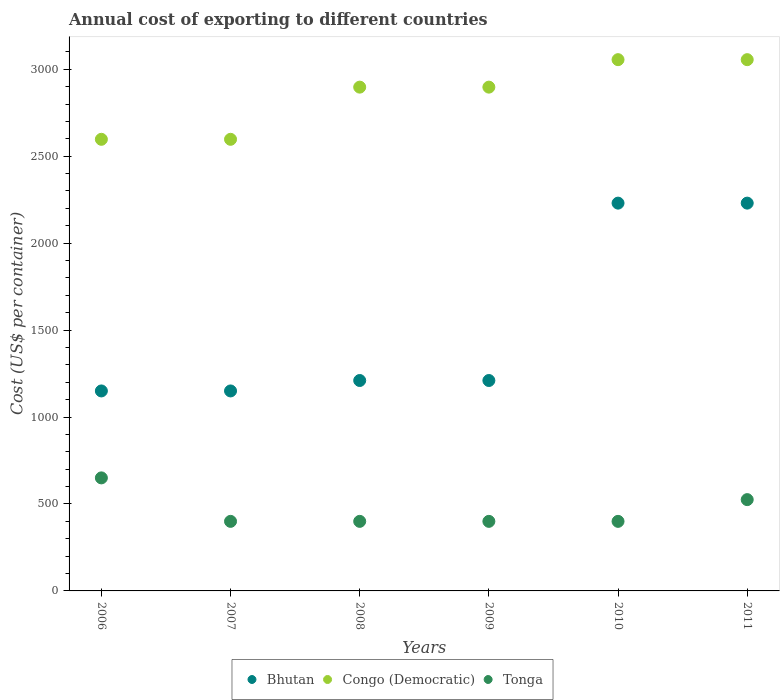What is the total annual cost of exporting in Bhutan in 2006?
Offer a terse response. 1150. Across all years, what is the maximum total annual cost of exporting in Congo (Democratic)?
Your answer should be very brief. 3055. Across all years, what is the minimum total annual cost of exporting in Bhutan?
Offer a terse response. 1150. In which year was the total annual cost of exporting in Bhutan maximum?
Offer a very short reply. 2010. What is the total total annual cost of exporting in Tonga in the graph?
Make the answer very short. 2775. What is the difference between the total annual cost of exporting in Bhutan in 2008 and the total annual cost of exporting in Congo (Democratic) in 2007?
Provide a succinct answer. -1387. What is the average total annual cost of exporting in Bhutan per year?
Offer a terse response. 1530. In the year 2006, what is the difference between the total annual cost of exporting in Tonga and total annual cost of exporting in Bhutan?
Keep it short and to the point. -500. In how many years, is the total annual cost of exporting in Tonga greater than 2100 US$?
Make the answer very short. 0. What is the ratio of the total annual cost of exporting in Tonga in 2008 to that in 2011?
Your answer should be compact. 0.76. Is the total annual cost of exporting in Congo (Democratic) in 2010 less than that in 2011?
Provide a succinct answer. No. Is the difference between the total annual cost of exporting in Tonga in 2008 and 2010 greater than the difference between the total annual cost of exporting in Bhutan in 2008 and 2010?
Your answer should be very brief. Yes. What is the difference between the highest and the second highest total annual cost of exporting in Tonga?
Your answer should be compact. 125. What is the difference between the highest and the lowest total annual cost of exporting in Tonga?
Provide a short and direct response. 250. Is the sum of the total annual cost of exporting in Bhutan in 2007 and 2009 greater than the maximum total annual cost of exporting in Tonga across all years?
Your response must be concise. Yes. Is the total annual cost of exporting in Bhutan strictly greater than the total annual cost of exporting in Tonga over the years?
Your answer should be very brief. Yes. Is the total annual cost of exporting in Congo (Democratic) strictly less than the total annual cost of exporting in Tonga over the years?
Make the answer very short. No. How many dotlines are there?
Offer a very short reply. 3. How many years are there in the graph?
Make the answer very short. 6. Does the graph contain any zero values?
Your answer should be compact. No. Does the graph contain grids?
Ensure brevity in your answer.  No. How many legend labels are there?
Your answer should be very brief. 3. How are the legend labels stacked?
Keep it short and to the point. Horizontal. What is the title of the graph?
Offer a very short reply. Annual cost of exporting to different countries. Does "Australia" appear as one of the legend labels in the graph?
Your response must be concise. No. What is the label or title of the X-axis?
Your answer should be compact. Years. What is the label or title of the Y-axis?
Your response must be concise. Cost (US$ per container). What is the Cost (US$ per container) of Bhutan in 2006?
Provide a succinct answer. 1150. What is the Cost (US$ per container) in Congo (Democratic) in 2006?
Offer a terse response. 2597. What is the Cost (US$ per container) of Tonga in 2006?
Your answer should be very brief. 650. What is the Cost (US$ per container) in Bhutan in 2007?
Keep it short and to the point. 1150. What is the Cost (US$ per container) of Congo (Democratic) in 2007?
Your answer should be compact. 2597. What is the Cost (US$ per container) in Tonga in 2007?
Ensure brevity in your answer.  400. What is the Cost (US$ per container) of Bhutan in 2008?
Keep it short and to the point. 1210. What is the Cost (US$ per container) of Congo (Democratic) in 2008?
Offer a terse response. 2897. What is the Cost (US$ per container) in Tonga in 2008?
Keep it short and to the point. 400. What is the Cost (US$ per container) of Bhutan in 2009?
Your response must be concise. 1210. What is the Cost (US$ per container) of Congo (Democratic) in 2009?
Provide a short and direct response. 2897. What is the Cost (US$ per container) of Tonga in 2009?
Your response must be concise. 400. What is the Cost (US$ per container) in Bhutan in 2010?
Offer a very short reply. 2230. What is the Cost (US$ per container) in Congo (Democratic) in 2010?
Ensure brevity in your answer.  3055. What is the Cost (US$ per container) of Tonga in 2010?
Provide a short and direct response. 400. What is the Cost (US$ per container) of Bhutan in 2011?
Give a very brief answer. 2230. What is the Cost (US$ per container) of Congo (Democratic) in 2011?
Provide a short and direct response. 3055. What is the Cost (US$ per container) of Tonga in 2011?
Offer a very short reply. 525. Across all years, what is the maximum Cost (US$ per container) of Bhutan?
Provide a short and direct response. 2230. Across all years, what is the maximum Cost (US$ per container) of Congo (Democratic)?
Give a very brief answer. 3055. Across all years, what is the maximum Cost (US$ per container) of Tonga?
Keep it short and to the point. 650. Across all years, what is the minimum Cost (US$ per container) in Bhutan?
Provide a short and direct response. 1150. Across all years, what is the minimum Cost (US$ per container) in Congo (Democratic)?
Your response must be concise. 2597. What is the total Cost (US$ per container) of Bhutan in the graph?
Offer a terse response. 9180. What is the total Cost (US$ per container) of Congo (Democratic) in the graph?
Your answer should be very brief. 1.71e+04. What is the total Cost (US$ per container) of Tonga in the graph?
Provide a short and direct response. 2775. What is the difference between the Cost (US$ per container) in Bhutan in 2006 and that in 2007?
Provide a short and direct response. 0. What is the difference between the Cost (US$ per container) of Tonga in 2006 and that in 2007?
Ensure brevity in your answer.  250. What is the difference between the Cost (US$ per container) of Bhutan in 2006 and that in 2008?
Make the answer very short. -60. What is the difference between the Cost (US$ per container) in Congo (Democratic) in 2006 and that in 2008?
Give a very brief answer. -300. What is the difference between the Cost (US$ per container) in Tonga in 2006 and that in 2008?
Provide a succinct answer. 250. What is the difference between the Cost (US$ per container) of Bhutan in 2006 and that in 2009?
Ensure brevity in your answer.  -60. What is the difference between the Cost (US$ per container) in Congo (Democratic) in 2006 and that in 2009?
Your response must be concise. -300. What is the difference between the Cost (US$ per container) of Tonga in 2006 and that in 2009?
Keep it short and to the point. 250. What is the difference between the Cost (US$ per container) of Bhutan in 2006 and that in 2010?
Give a very brief answer. -1080. What is the difference between the Cost (US$ per container) in Congo (Democratic) in 2006 and that in 2010?
Ensure brevity in your answer.  -458. What is the difference between the Cost (US$ per container) in Tonga in 2006 and that in 2010?
Make the answer very short. 250. What is the difference between the Cost (US$ per container) of Bhutan in 2006 and that in 2011?
Your answer should be very brief. -1080. What is the difference between the Cost (US$ per container) in Congo (Democratic) in 2006 and that in 2011?
Your answer should be very brief. -458. What is the difference between the Cost (US$ per container) of Tonga in 2006 and that in 2011?
Your answer should be compact. 125. What is the difference between the Cost (US$ per container) of Bhutan in 2007 and that in 2008?
Offer a terse response. -60. What is the difference between the Cost (US$ per container) in Congo (Democratic) in 2007 and that in 2008?
Give a very brief answer. -300. What is the difference between the Cost (US$ per container) of Bhutan in 2007 and that in 2009?
Your response must be concise. -60. What is the difference between the Cost (US$ per container) in Congo (Democratic) in 2007 and that in 2009?
Offer a terse response. -300. What is the difference between the Cost (US$ per container) in Tonga in 2007 and that in 2009?
Your answer should be compact. 0. What is the difference between the Cost (US$ per container) in Bhutan in 2007 and that in 2010?
Keep it short and to the point. -1080. What is the difference between the Cost (US$ per container) in Congo (Democratic) in 2007 and that in 2010?
Provide a succinct answer. -458. What is the difference between the Cost (US$ per container) in Tonga in 2007 and that in 2010?
Make the answer very short. 0. What is the difference between the Cost (US$ per container) in Bhutan in 2007 and that in 2011?
Give a very brief answer. -1080. What is the difference between the Cost (US$ per container) in Congo (Democratic) in 2007 and that in 2011?
Offer a very short reply. -458. What is the difference between the Cost (US$ per container) in Tonga in 2007 and that in 2011?
Keep it short and to the point. -125. What is the difference between the Cost (US$ per container) in Tonga in 2008 and that in 2009?
Give a very brief answer. 0. What is the difference between the Cost (US$ per container) of Bhutan in 2008 and that in 2010?
Give a very brief answer. -1020. What is the difference between the Cost (US$ per container) of Congo (Democratic) in 2008 and that in 2010?
Ensure brevity in your answer.  -158. What is the difference between the Cost (US$ per container) of Tonga in 2008 and that in 2010?
Your answer should be very brief. 0. What is the difference between the Cost (US$ per container) in Bhutan in 2008 and that in 2011?
Provide a succinct answer. -1020. What is the difference between the Cost (US$ per container) in Congo (Democratic) in 2008 and that in 2011?
Your answer should be compact. -158. What is the difference between the Cost (US$ per container) of Tonga in 2008 and that in 2011?
Your response must be concise. -125. What is the difference between the Cost (US$ per container) of Bhutan in 2009 and that in 2010?
Offer a very short reply. -1020. What is the difference between the Cost (US$ per container) of Congo (Democratic) in 2009 and that in 2010?
Your answer should be compact. -158. What is the difference between the Cost (US$ per container) of Tonga in 2009 and that in 2010?
Provide a short and direct response. 0. What is the difference between the Cost (US$ per container) of Bhutan in 2009 and that in 2011?
Offer a terse response. -1020. What is the difference between the Cost (US$ per container) of Congo (Democratic) in 2009 and that in 2011?
Offer a terse response. -158. What is the difference between the Cost (US$ per container) in Tonga in 2009 and that in 2011?
Keep it short and to the point. -125. What is the difference between the Cost (US$ per container) of Bhutan in 2010 and that in 2011?
Your response must be concise. 0. What is the difference between the Cost (US$ per container) in Congo (Democratic) in 2010 and that in 2011?
Make the answer very short. 0. What is the difference between the Cost (US$ per container) of Tonga in 2010 and that in 2011?
Ensure brevity in your answer.  -125. What is the difference between the Cost (US$ per container) of Bhutan in 2006 and the Cost (US$ per container) of Congo (Democratic) in 2007?
Ensure brevity in your answer.  -1447. What is the difference between the Cost (US$ per container) in Bhutan in 2006 and the Cost (US$ per container) in Tonga in 2007?
Offer a terse response. 750. What is the difference between the Cost (US$ per container) in Congo (Democratic) in 2006 and the Cost (US$ per container) in Tonga in 2007?
Provide a succinct answer. 2197. What is the difference between the Cost (US$ per container) of Bhutan in 2006 and the Cost (US$ per container) of Congo (Democratic) in 2008?
Provide a short and direct response. -1747. What is the difference between the Cost (US$ per container) in Bhutan in 2006 and the Cost (US$ per container) in Tonga in 2008?
Give a very brief answer. 750. What is the difference between the Cost (US$ per container) in Congo (Democratic) in 2006 and the Cost (US$ per container) in Tonga in 2008?
Give a very brief answer. 2197. What is the difference between the Cost (US$ per container) of Bhutan in 2006 and the Cost (US$ per container) of Congo (Democratic) in 2009?
Your answer should be very brief. -1747. What is the difference between the Cost (US$ per container) of Bhutan in 2006 and the Cost (US$ per container) of Tonga in 2009?
Your response must be concise. 750. What is the difference between the Cost (US$ per container) of Congo (Democratic) in 2006 and the Cost (US$ per container) of Tonga in 2009?
Offer a very short reply. 2197. What is the difference between the Cost (US$ per container) of Bhutan in 2006 and the Cost (US$ per container) of Congo (Democratic) in 2010?
Provide a succinct answer. -1905. What is the difference between the Cost (US$ per container) of Bhutan in 2006 and the Cost (US$ per container) of Tonga in 2010?
Keep it short and to the point. 750. What is the difference between the Cost (US$ per container) in Congo (Democratic) in 2006 and the Cost (US$ per container) in Tonga in 2010?
Make the answer very short. 2197. What is the difference between the Cost (US$ per container) of Bhutan in 2006 and the Cost (US$ per container) of Congo (Democratic) in 2011?
Offer a terse response. -1905. What is the difference between the Cost (US$ per container) of Bhutan in 2006 and the Cost (US$ per container) of Tonga in 2011?
Provide a short and direct response. 625. What is the difference between the Cost (US$ per container) of Congo (Democratic) in 2006 and the Cost (US$ per container) of Tonga in 2011?
Offer a terse response. 2072. What is the difference between the Cost (US$ per container) of Bhutan in 2007 and the Cost (US$ per container) of Congo (Democratic) in 2008?
Provide a short and direct response. -1747. What is the difference between the Cost (US$ per container) in Bhutan in 2007 and the Cost (US$ per container) in Tonga in 2008?
Offer a terse response. 750. What is the difference between the Cost (US$ per container) in Congo (Democratic) in 2007 and the Cost (US$ per container) in Tonga in 2008?
Offer a terse response. 2197. What is the difference between the Cost (US$ per container) in Bhutan in 2007 and the Cost (US$ per container) in Congo (Democratic) in 2009?
Give a very brief answer. -1747. What is the difference between the Cost (US$ per container) in Bhutan in 2007 and the Cost (US$ per container) in Tonga in 2009?
Ensure brevity in your answer.  750. What is the difference between the Cost (US$ per container) in Congo (Democratic) in 2007 and the Cost (US$ per container) in Tonga in 2009?
Provide a short and direct response. 2197. What is the difference between the Cost (US$ per container) in Bhutan in 2007 and the Cost (US$ per container) in Congo (Democratic) in 2010?
Your answer should be compact. -1905. What is the difference between the Cost (US$ per container) of Bhutan in 2007 and the Cost (US$ per container) of Tonga in 2010?
Your response must be concise. 750. What is the difference between the Cost (US$ per container) in Congo (Democratic) in 2007 and the Cost (US$ per container) in Tonga in 2010?
Offer a very short reply. 2197. What is the difference between the Cost (US$ per container) in Bhutan in 2007 and the Cost (US$ per container) in Congo (Democratic) in 2011?
Your answer should be compact. -1905. What is the difference between the Cost (US$ per container) of Bhutan in 2007 and the Cost (US$ per container) of Tonga in 2011?
Your answer should be compact. 625. What is the difference between the Cost (US$ per container) of Congo (Democratic) in 2007 and the Cost (US$ per container) of Tonga in 2011?
Your answer should be very brief. 2072. What is the difference between the Cost (US$ per container) in Bhutan in 2008 and the Cost (US$ per container) in Congo (Democratic) in 2009?
Ensure brevity in your answer.  -1687. What is the difference between the Cost (US$ per container) in Bhutan in 2008 and the Cost (US$ per container) in Tonga in 2009?
Provide a short and direct response. 810. What is the difference between the Cost (US$ per container) of Congo (Democratic) in 2008 and the Cost (US$ per container) of Tonga in 2009?
Your answer should be compact. 2497. What is the difference between the Cost (US$ per container) in Bhutan in 2008 and the Cost (US$ per container) in Congo (Democratic) in 2010?
Give a very brief answer. -1845. What is the difference between the Cost (US$ per container) in Bhutan in 2008 and the Cost (US$ per container) in Tonga in 2010?
Offer a terse response. 810. What is the difference between the Cost (US$ per container) of Congo (Democratic) in 2008 and the Cost (US$ per container) of Tonga in 2010?
Your response must be concise. 2497. What is the difference between the Cost (US$ per container) in Bhutan in 2008 and the Cost (US$ per container) in Congo (Democratic) in 2011?
Ensure brevity in your answer.  -1845. What is the difference between the Cost (US$ per container) of Bhutan in 2008 and the Cost (US$ per container) of Tonga in 2011?
Make the answer very short. 685. What is the difference between the Cost (US$ per container) of Congo (Democratic) in 2008 and the Cost (US$ per container) of Tonga in 2011?
Provide a short and direct response. 2372. What is the difference between the Cost (US$ per container) in Bhutan in 2009 and the Cost (US$ per container) in Congo (Democratic) in 2010?
Your response must be concise. -1845. What is the difference between the Cost (US$ per container) of Bhutan in 2009 and the Cost (US$ per container) of Tonga in 2010?
Provide a short and direct response. 810. What is the difference between the Cost (US$ per container) of Congo (Democratic) in 2009 and the Cost (US$ per container) of Tonga in 2010?
Provide a succinct answer. 2497. What is the difference between the Cost (US$ per container) in Bhutan in 2009 and the Cost (US$ per container) in Congo (Democratic) in 2011?
Your answer should be compact. -1845. What is the difference between the Cost (US$ per container) of Bhutan in 2009 and the Cost (US$ per container) of Tonga in 2011?
Give a very brief answer. 685. What is the difference between the Cost (US$ per container) in Congo (Democratic) in 2009 and the Cost (US$ per container) in Tonga in 2011?
Provide a succinct answer. 2372. What is the difference between the Cost (US$ per container) of Bhutan in 2010 and the Cost (US$ per container) of Congo (Democratic) in 2011?
Offer a terse response. -825. What is the difference between the Cost (US$ per container) in Bhutan in 2010 and the Cost (US$ per container) in Tonga in 2011?
Your response must be concise. 1705. What is the difference between the Cost (US$ per container) of Congo (Democratic) in 2010 and the Cost (US$ per container) of Tonga in 2011?
Ensure brevity in your answer.  2530. What is the average Cost (US$ per container) of Bhutan per year?
Offer a terse response. 1530. What is the average Cost (US$ per container) of Congo (Democratic) per year?
Ensure brevity in your answer.  2849.67. What is the average Cost (US$ per container) in Tonga per year?
Keep it short and to the point. 462.5. In the year 2006, what is the difference between the Cost (US$ per container) in Bhutan and Cost (US$ per container) in Congo (Democratic)?
Make the answer very short. -1447. In the year 2006, what is the difference between the Cost (US$ per container) of Bhutan and Cost (US$ per container) of Tonga?
Give a very brief answer. 500. In the year 2006, what is the difference between the Cost (US$ per container) of Congo (Democratic) and Cost (US$ per container) of Tonga?
Your answer should be very brief. 1947. In the year 2007, what is the difference between the Cost (US$ per container) of Bhutan and Cost (US$ per container) of Congo (Democratic)?
Your response must be concise. -1447. In the year 2007, what is the difference between the Cost (US$ per container) in Bhutan and Cost (US$ per container) in Tonga?
Give a very brief answer. 750. In the year 2007, what is the difference between the Cost (US$ per container) of Congo (Democratic) and Cost (US$ per container) of Tonga?
Give a very brief answer. 2197. In the year 2008, what is the difference between the Cost (US$ per container) of Bhutan and Cost (US$ per container) of Congo (Democratic)?
Your answer should be very brief. -1687. In the year 2008, what is the difference between the Cost (US$ per container) in Bhutan and Cost (US$ per container) in Tonga?
Provide a short and direct response. 810. In the year 2008, what is the difference between the Cost (US$ per container) of Congo (Democratic) and Cost (US$ per container) of Tonga?
Make the answer very short. 2497. In the year 2009, what is the difference between the Cost (US$ per container) in Bhutan and Cost (US$ per container) in Congo (Democratic)?
Offer a terse response. -1687. In the year 2009, what is the difference between the Cost (US$ per container) of Bhutan and Cost (US$ per container) of Tonga?
Offer a terse response. 810. In the year 2009, what is the difference between the Cost (US$ per container) in Congo (Democratic) and Cost (US$ per container) in Tonga?
Provide a succinct answer. 2497. In the year 2010, what is the difference between the Cost (US$ per container) of Bhutan and Cost (US$ per container) of Congo (Democratic)?
Your response must be concise. -825. In the year 2010, what is the difference between the Cost (US$ per container) of Bhutan and Cost (US$ per container) of Tonga?
Offer a terse response. 1830. In the year 2010, what is the difference between the Cost (US$ per container) of Congo (Democratic) and Cost (US$ per container) of Tonga?
Your response must be concise. 2655. In the year 2011, what is the difference between the Cost (US$ per container) in Bhutan and Cost (US$ per container) in Congo (Democratic)?
Ensure brevity in your answer.  -825. In the year 2011, what is the difference between the Cost (US$ per container) in Bhutan and Cost (US$ per container) in Tonga?
Provide a succinct answer. 1705. In the year 2011, what is the difference between the Cost (US$ per container) of Congo (Democratic) and Cost (US$ per container) of Tonga?
Offer a very short reply. 2530. What is the ratio of the Cost (US$ per container) of Tonga in 2006 to that in 2007?
Give a very brief answer. 1.62. What is the ratio of the Cost (US$ per container) of Bhutan in 2006 to that in 2008?
Ensure brevity in your answer.  0.95. What is the ratio of the Cost (US$ per container) in Congo (Democratic) in 2006 to that in 2008?
Provide a succinct answer. 0.9. What is the ratio of the Cost (US$ per container) in Tonga in 2006 to that in 2008?
Offer a very short reply. 1.62. What is the ratio of the Cost (US$ per container) of Bhutan in 2006 to that in 2009?
Your answer should be compact. 0.95. What is the ratio of the Cost (US$ per container) of Congo (Democratic) in 2006 to that in 2009?
Offer a very short reply. 0.9. What is the ratio of the Cost (US$ per container) of Tonga in 2006 to that in 2009?
Provide a short and direct response. 1.62. What is the ratio of the Cost (US$ per container) in Bhutan in 2006 to that in 2010?
Your answer should be compact. 0.52. What is the ratio of the Cost (US$ per container) of Congo (Democratic) in 2006 to that in 2010?
Your response must be concise. 0.85. What is the ratio of the Cost (US$ per container) of Tonga in 2006 to that in 2010?
Your answer should be very brief. 1.62. What is the ratio of the Cost (US$ per container) of Bhutan in 2006 to that in 2011?
Offer a terse response. 0.52. What is the ratio of the Cost (US$ per container) of Congo (Democratic) in 2006 to that in 2011?
Keep it short and to the point. 0.85. What is the ratio of the Cost (US$ per container) in Tonga in 2006 to that in 2011?
Give a very brief answer. 1.24. What is the ratio of the Cost (US$ per container) in Bhutan in 2007 to that in 2008?
Your answer should be compact. 0.95. What is the ratio of the Cost (US$ per container) in Congo (Democratic) in 2007 to that in 2008?
Offer a very short reply. 0.9. What is the ratio of the Cost (US$ per container) of Bhutan in 2007 to that in 2009?
Keep it short and to the point. 0.95. What is the ratio of the Cost (US$ per container) in Congo (Democratic) in 2007 to that in 2009?
Give a very brief answer. 0.9. What is the ratio of the Cost (US$ per container) of Bhutan in 2007 to that in 2010?
Keep it short and to the point. 0.52. What is the ratio of the Cost (US$ per container) in Congo (Democratic) in 2007 to that in 2010?
Give a very brief answer. 0.85. What is the ratio of the Cost (US$ per container) in Bhutan in 2007 to that in 2011?
Provide a succinct answer. 0.52. What is the ratio of the Cost (US$ per container) of Congo (Democratic) in 2007 to that in 2011?
Offer a very short reply. 0.85. What is the ratio of the Cost (US$ per container) in Tonga in 2007 to that in 2011?
Ensure brevity in your answer.  0.76. What is the ratio of the Cost (US$ per container) of Bhutan in 2008 to that in 2009?
Your answer should be very brief. 1. What is the ratio of the Cost (US$ per container) in Congo (Democratic) in 2008 to that in 2009?
Ensure brevity in your answer.  1. What is the ratio of the Cost (US$ per container) of Bhutan in 2008 to that in 2010?
Offer a terse response. 0.54. What is the ratio of the Cost (US$ per container) of Congo (Democratic) in 2008 to that in 2010?
Your response must be concise. 0.95. What is the ratio of the Cost (US$ per container) of Bhutan in 2008 to that in 2011?
Offer a very short reply. 0.54. What is the ratio of the Cost (US$ per container) of Congo (Democratic) in 2008 to that in 2011?
Make the answer very short. 0.95. What is the ratio of the Cost (US$ per container) in Tonga in 2008 to that in 2011?
Ensure brevity in your answer.  0.76. What is the ratio of the Cost (US$ per container) in Bhutan in 2009 to that in 2010?
Make the answer very short. 0.54. What is the ratio of the Cost (US$ per container) of Congo (Democratic) in 2009 to that in 2010?
Provide a short and direct response. 0.95. What is the ratio of the Cost (US$ per container) of Bhutan in 2009 to that in 2011?
Give a very brief answer. 0.54. What is the ratio of the Cost (US$ per container) of Congo (Democratic) in 2009 to that in 2011?
Your response must be concise. 0.95. What is the ratio of the Cost (US$ per container) in Tonga in 2009 to that in 2011?
Make the answer very short. 0.76. What is the ratio of the Cost (US$ per container) in Bhutan in 2010 to that in 2011?
Make the answer very short. 1. What is the ratio of the Cost (US$ per container) of Tonga in 2010 to that in 2011?
Provide a short and direct response. 0.76. What is the difference between the highest and the second highest Cost (US$ per container) in Bhutan?
Ensure brevity in your answer.  0. What is the difference between the highest and the second highest Cost (US$ per container) of Tonga?
Give a very brief answer. 125. What is the difference between the highest and the lowest Cost (US$ per container) of Bhutan?
Your answer should be very brief. 1080. What is the difference between the highest and the lowest Cost (US$ per container) of Congo (Democratic)?
Offer a very short reply. 458. What is the difference between the highest and the lowest Cost (US$ per container) in Tonga?
Provide a succinct answer. 250. 